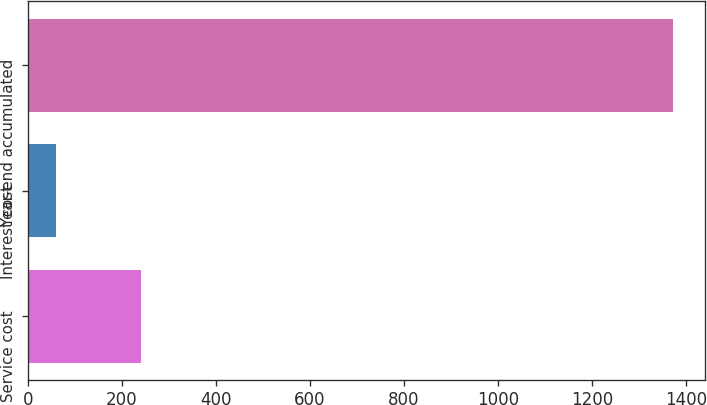Convert chart to OTSL. <chart><loc_0><loc_0><loc_500><loc_500><bar_chart><fcel>Service cost<fcel>Interest cost<fcel>Year-end accumulated<nl><fcel>241<fcel>60<fcel>1373<nl></chart> 